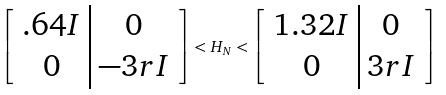Convert formula to latex. <formula><loc_0><loc_0><loc_500><loc_500>\left [ \begin{array} { c | c } . 6 4 I & 0 \\ 0 & - 3 r I \end{array} \right ] < H _ { N } < \left [ \begin{array} { c | c } 1 . 3 2 I & 0 \\ 0 & 3 r I \end{array} \right ]</formula> 